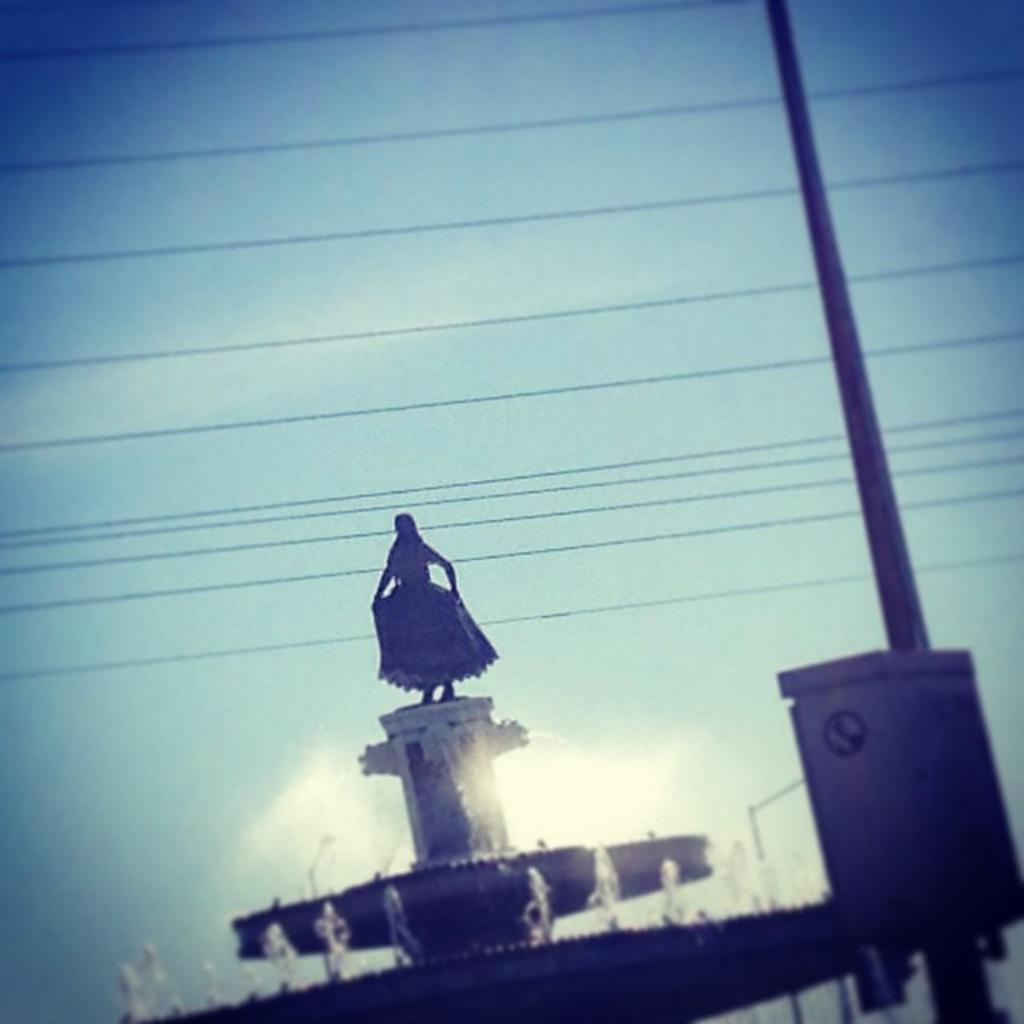In one or two sentences, can you explain what this image depicts? In this picture we can see the sky, wires. We can see the statue of a woman placed on a pedestal and we can also see the water fountain. On the right side of the picture we can see a pole and a box. 